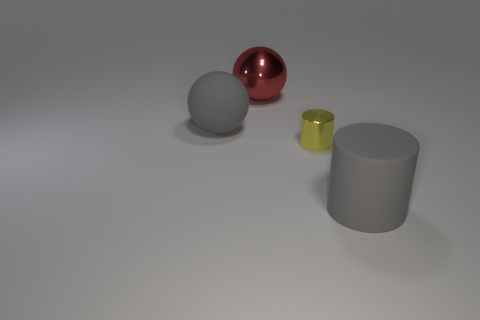Add 2 yellow metal things. How many objects exist? 6 Subtract 1 balls. How many balls are left? 1 Subtract all gray spheres. How many spheres are left? 1 Subtract all purple cylinders. Subtract all gray spheres. How many cylinders are left? 2 Subtract all red balls. How many gray cylinders are left? 1 Add 2 small yellow things. How many small yellow things are left? 3 Add 3 large gray matte objects. How many large gray matte objects exist? 5 Subtract 0 gray cubes. How many objects are left? 4 Subtract all large rubber cylinders. Subtract all matte spheres. How many objects are left? 2 